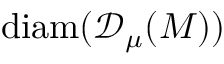<formula> <loc_0><loc_0><loc_500><loc_500>d i a m ( { \ m a t h s c r { D } _ { \mu } ( M ) } )</formula> 